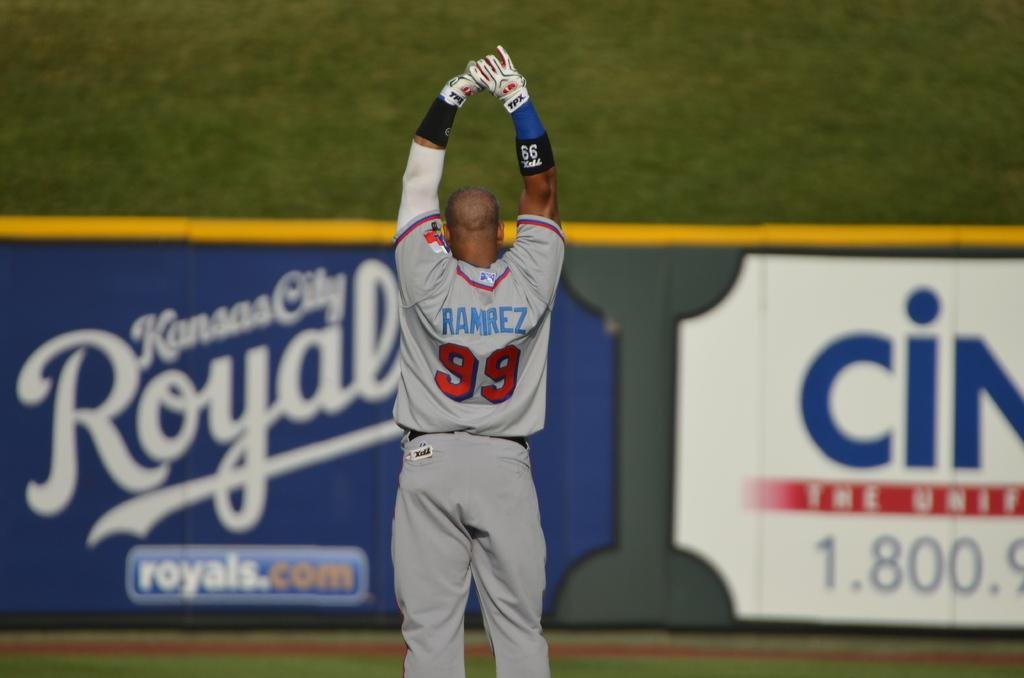<image>
Offer a succinct explanation of the picture presented. A man wearing baseball jersey number 99 is standing with his hands over his head. 